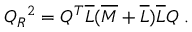<formula> <loc_0><loc_0><loc_500><loc_500>Q _ { R ^ { 2 } = Q ^ { T } \overline { L } ( \overline { M } + \overline { L } ) \overline { L } Q \ .</formula> 